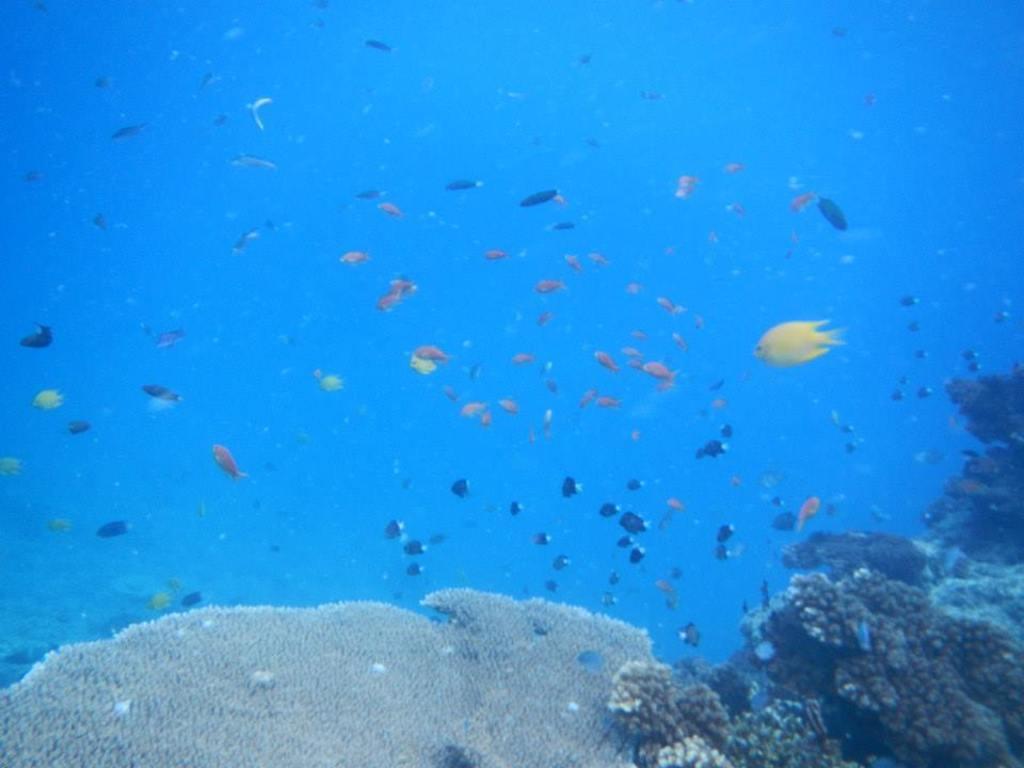Could you give a brief overview of what you see in this image? In the image there are fishes swimming in the water and under the water there are some aquatic plants. 